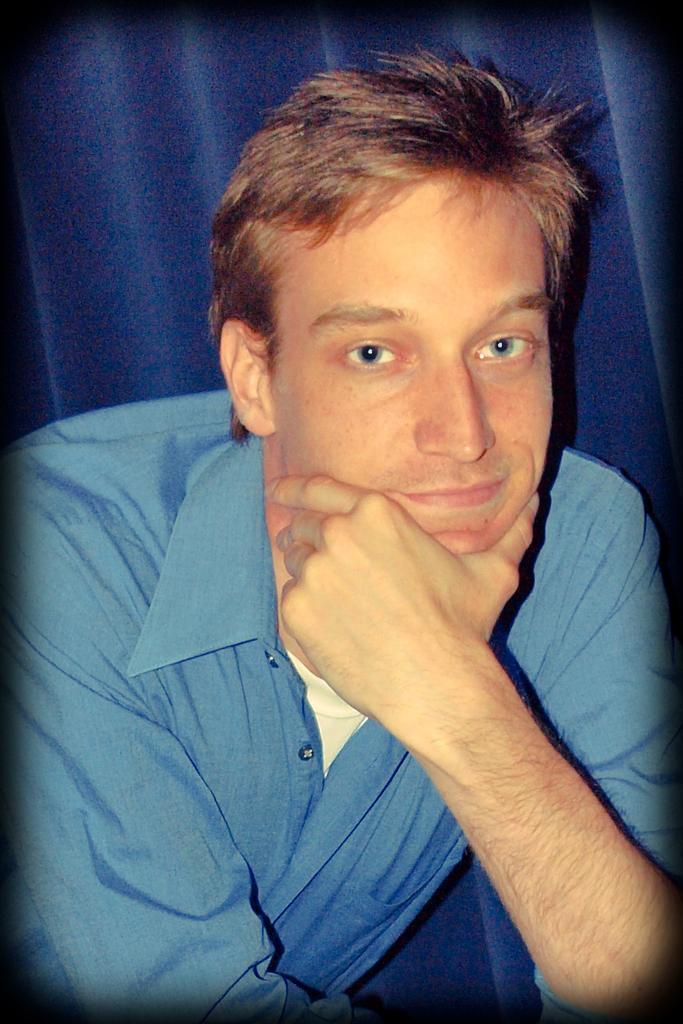Please provide a concise description of this image. In this image we can see a man. In the background there is curtain. 